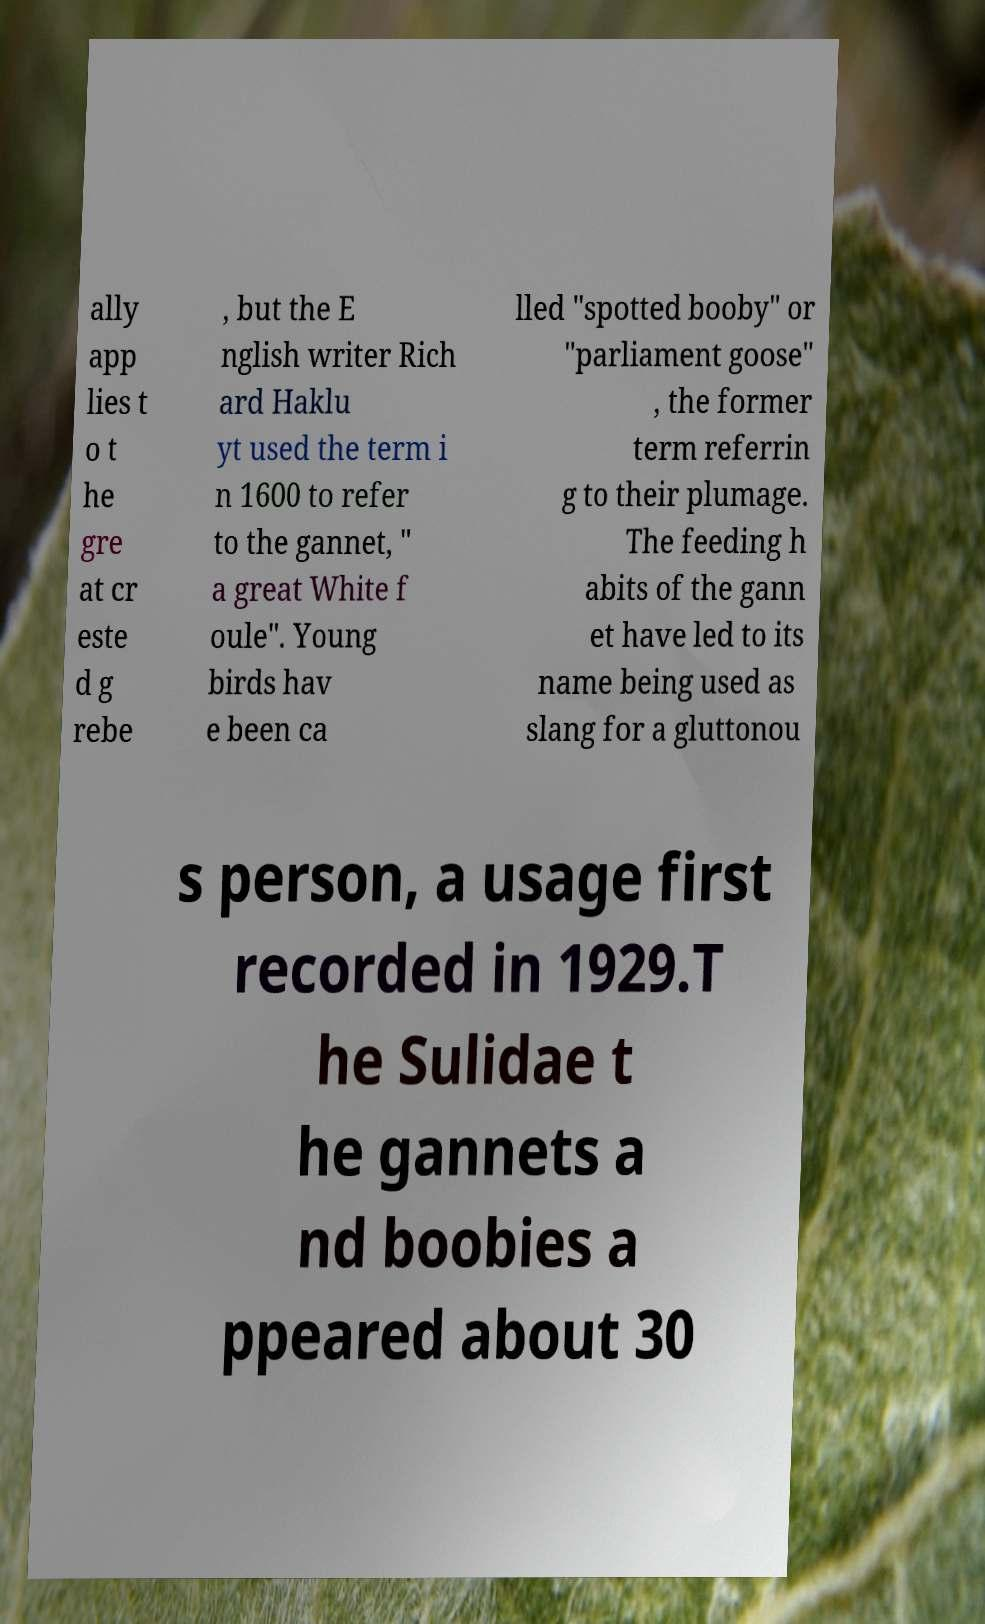For documentation purposes, I need the text within this image transcribed. Could you provide that? ally app lies t o t he gre at cr este d g rebe , but the E nglish writer Rich ard Haklu yt used the term i n 1600 to refer to the gannet, " a great White f oule". Young birds hav e been ca lled "spotted booby" or "parliament goose" , the former term referrin g to their plumage. The feeding h abits of the gann et have led to its name being used as slang for a gluttonou s person, a usage first recorded in 1929.T he Sulidae t he gannets a nd boobies a ppeared about 30 